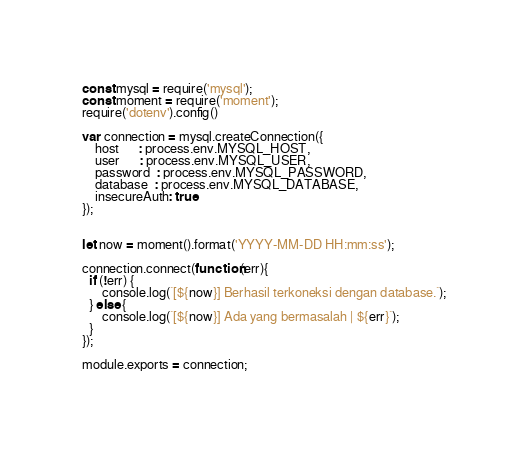Convert code to text. <code><loc_0><loc_0><loc_500><loc_500><_JavaScript_>const mysql = require('mysql');
const moment = require('moment');
require('dotenv').config()

var connection = mysql.createConnection({
    host      : process.env.MYSQL_HOST,
    user      : process.env.MYSQL_USER,
    password  : process.env.MYSQL_PASSWORD,
    database  : process.env.MYSQL_DATABASE,
    insecureAuth: true
});


let now = moment().format('YYYY-MM-DD HH:mm:ss');

connection.connect(function(err){
  if (!err) {
      console.log(`[${now}] Berhasil terkoneksi dengan database.`);
  } else {
      console.log(`[${now}] Ada yang bermasalah | ${err}`);
  }
});

module.exports = connection; </code> 